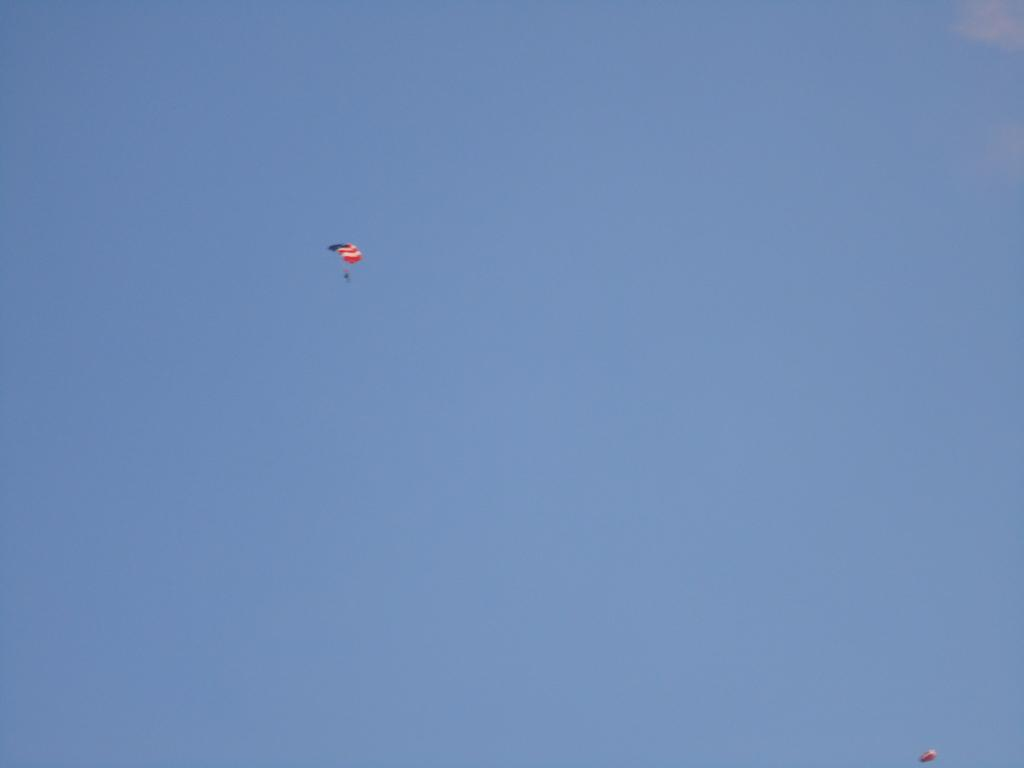What can be seen in the sky in the image? There is a parachute in the sky. Are there any other parachutes visible in the image? Yes, there is another parachute at the right side bottom corner. What is the condition of the sky in the image? The sky is clear in the image. What type of rhythm can be heard coming from the parachute in the image? There is no sound or rhythm associated with the parachutes in the image. Can you tell me the size of the marble used to create the parachute in the image? There is no marble used to create the parachute in the image; it is made of fabric and other materials. 